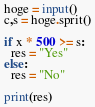<code> <loc_0><loc_0><loc_500><loc_500><_Python_>hoge = input()
c,s = hoge.sprit()

if x * 500 >= s:
  res = "Yes"
else:
  res = "No"
  
print(res)</code> 